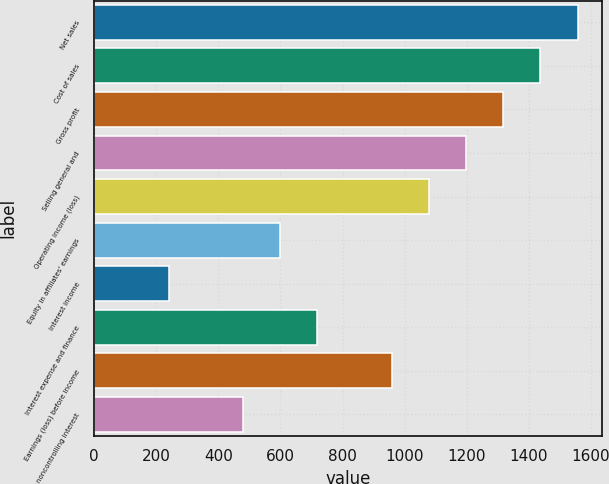Convert chart to OTSL. <chart><loc_0><loc_0><loc_500><loc_500><bar_chart><fcel>Net sales<fcel>Cost of sales<fcel>Gross profit<fcel>Selling general and<fcel>Operating income (loss)<fcel>Equity in affiliates' earnings<fcel>Interest income<fcel>Interest expense and finance<fcel>Earnings (loss) before income<fcel>noncontrolling interest<nl><fcel>1557.65<fcel>1437.87<fcel>1318.08<fcel>1198.29<fcel>1078.5<fcel>599.37<fcel>240.01<fcel>719.15<fcel>958.71<fcel>479.58<nl></chart> 